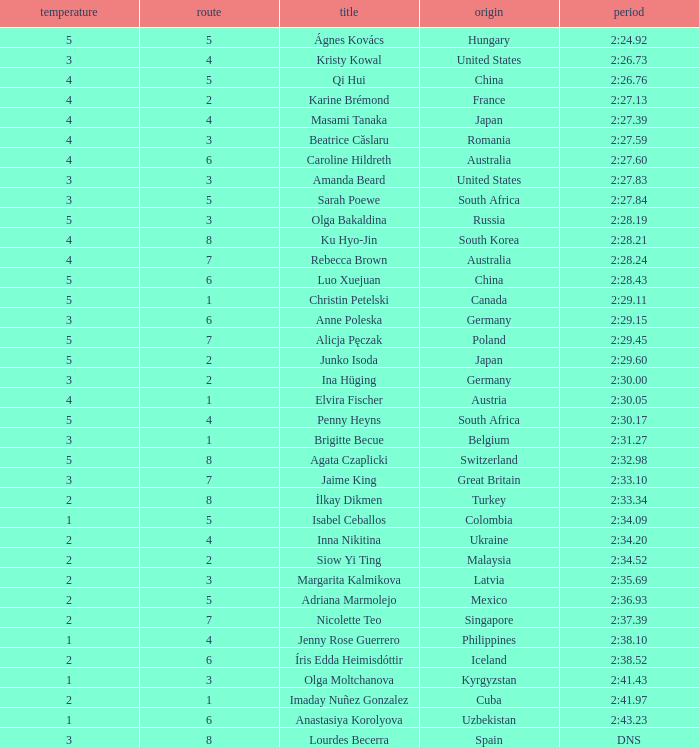What is the term that experienced 4 heat sessions and a track higher than 7? Ku Hyo-Jin. Write the full table. {'header': ['temperature', 'route', 'title', 'origin', 'period'], 'rows': [['5', '5', 'Ágnes Kovács', 'Hungary', '2:24.92'], ['3', '4', 'Kristy Kowal', 'United States', '2:26.73'], ['4', '5', 'Qi Hui', 'China', '2:26.76'], ['4', '2', 'Karine Brémond', 'France', '2:27.13'], ['4', '4', 'Masami Tanaka', 'Japan', '2:27.39'], ['4', '3', 'Beatrice Căslaru', 'Romania', '2:27.59'], ['4', '6', 'Caroline Hildreth', 'Australia', '2:27.60'], ['3', '3', 'Amanda Beard', 'United States', '2:27.83'], ['3', '5', 'Sarah Poewe', 'South Africa', '2:27.84'], ['5', '3', 'Olga Bakaldina', 'Russia', '2:28.19'], ['4', '8', 'Ku Hyo-Jin', 'South Korea', '2:28.21'], ['4', '7', 'Rebecca Brown', 'Australia', '2:28.24'], ['5', '6', 'Luo Xuejuan', 'China', '2:28.43'], ['5', '1', 'Christin Petelski', 'Canada', '2:29.11'], ['3', '6', 'Anne Poleska', 'Germany', '2:29.15'], ['5', '7', 'Alicja Pęczak', 'Poland', '2:29.45'], ['5', '2', 'Junko Isoda', 'Japan', '2:29.60'], ['3', '2', 'Ina Hüging', 'Germany', '2:30.00'], ['4', '1', 'Elvira Fischer', 'Austria', '2:30.05'], ['5', '4', 'Penny Heyns', 'South Africa', '2:30.17'], ['3', '1', 'Brigitte Becue', 'Belgium', '2:31.27'], ['5', '8', 'Agata Czaplicki', 'Switzerland', '2:32.98'], ['3', '7', 'Jaime King', 'Great Britain', '2:33.10'], ['2', '8', 'İlkay Dikmen', 'Turkey', '2:33.34'], ['1', '5', 'Isabel Ceballos', 'Colombia', '2:34.09'], ['2', '4', 'Inna Nikitina', 'Ukraine', '2:34.20'], ['2', '2', 'Siow Yi Ting', 'Malaysia', '2:34.52'], ['2', '3', 'Margarita Kalmikova', 'Latvia', '2:35.69'], ['2', '5', 'Adriana Marmolejo', 'Mexico', '2:36.93'], ['2', '7', 'Nicolette Teo', 'Singapore', '2:37.39'], ['1', '4', 'Jenny Rose Guerrero', 'Philippines', '2:38.10'], ['2', '6', 'Íris Edda Heimisdóttir', 'Iceland', '2:38.52'], ['1', '3', 'Olga Moltchanova', 'Kyrgyzstan', '2:41.43'], ['2', '1', 'Imaday Nuñez Gonzalez', 'Cuba', '2:41.97'], ['1', '6', 'Anastasiya Korolyova', 'Uzbekistan', '2:43.23'], ['3', '8', 'Lourdes Becerra', 'Spain', 'DNS']]} 